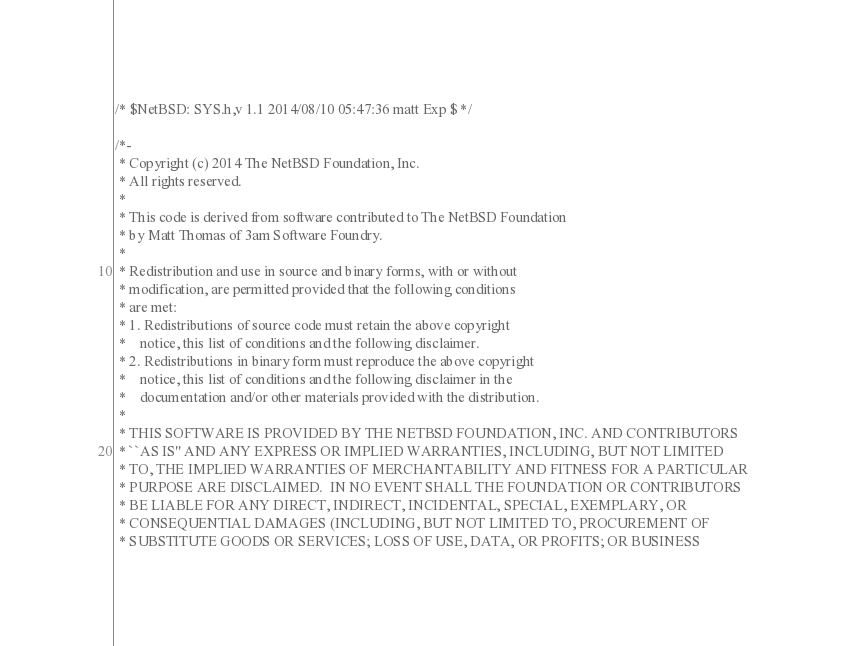<code> <loc_0><loc_0><loc_500><loc_500><_C_>/* $NetBSD: SYS.h,v 1.1 2014/08/10 05:47:36 matt Exp $ */

/*-
 * Copyright (c) 2014 The NetBSD Foundation, Inc.
 * All rights reserved.
 *
 * This code is derived from software contributed to The NetBSD Foundation
 * by Matt Thomas of 3am Software Foundry.
 *
 * Redistribution and use in source and binary forms, with or without
 * modification, are permitted provided that the following conditions
 * are met:
 * 1. Redistributions of source code must retain the above copyright
 *    notice, this list of conditions and the following disclaimer.
 * 2. Redistributions in binary form must reproduce the above copyright
 *    notice, this list of conditions and the following disclaimer in the
 *    documentation and/or other materials provided with the distribution.
 *
 * THIS SOFTWARE IS PROVIDED BY THE NETBSD FOUNDATION, INC. AND CONTRIBUTORS
 * ``AS IS'' AND ANY EXPRESS OR IMPLIED WARRANTIES, INCLUDING, BUT NOT LIMITED
 * TO, THE IMPLIED WARRANTIES OF MERCHANTABILITY AND FITNESS FOR A PARTICULAR
 * PURPOSE ARE DISCLAIMED.  IN NO EVENT SHALL THE FOUNDATION OR CONTRIBUTORS
 * BE LIABLE FOR ANY DIRECT, INDIRECT, INCIDENTAL, SPECIAL, EXEMPLARY, OR
 * CONSEQUENTIAL DAMAGES (INCLUDING, BUT NOT LIMITED TO, PROCUREMENT OF
 * SUBSTITUTE GOODS OR SERVICES; LOSS OF USE, DATA, OR PROFITS; OR BUSINESS</code> 